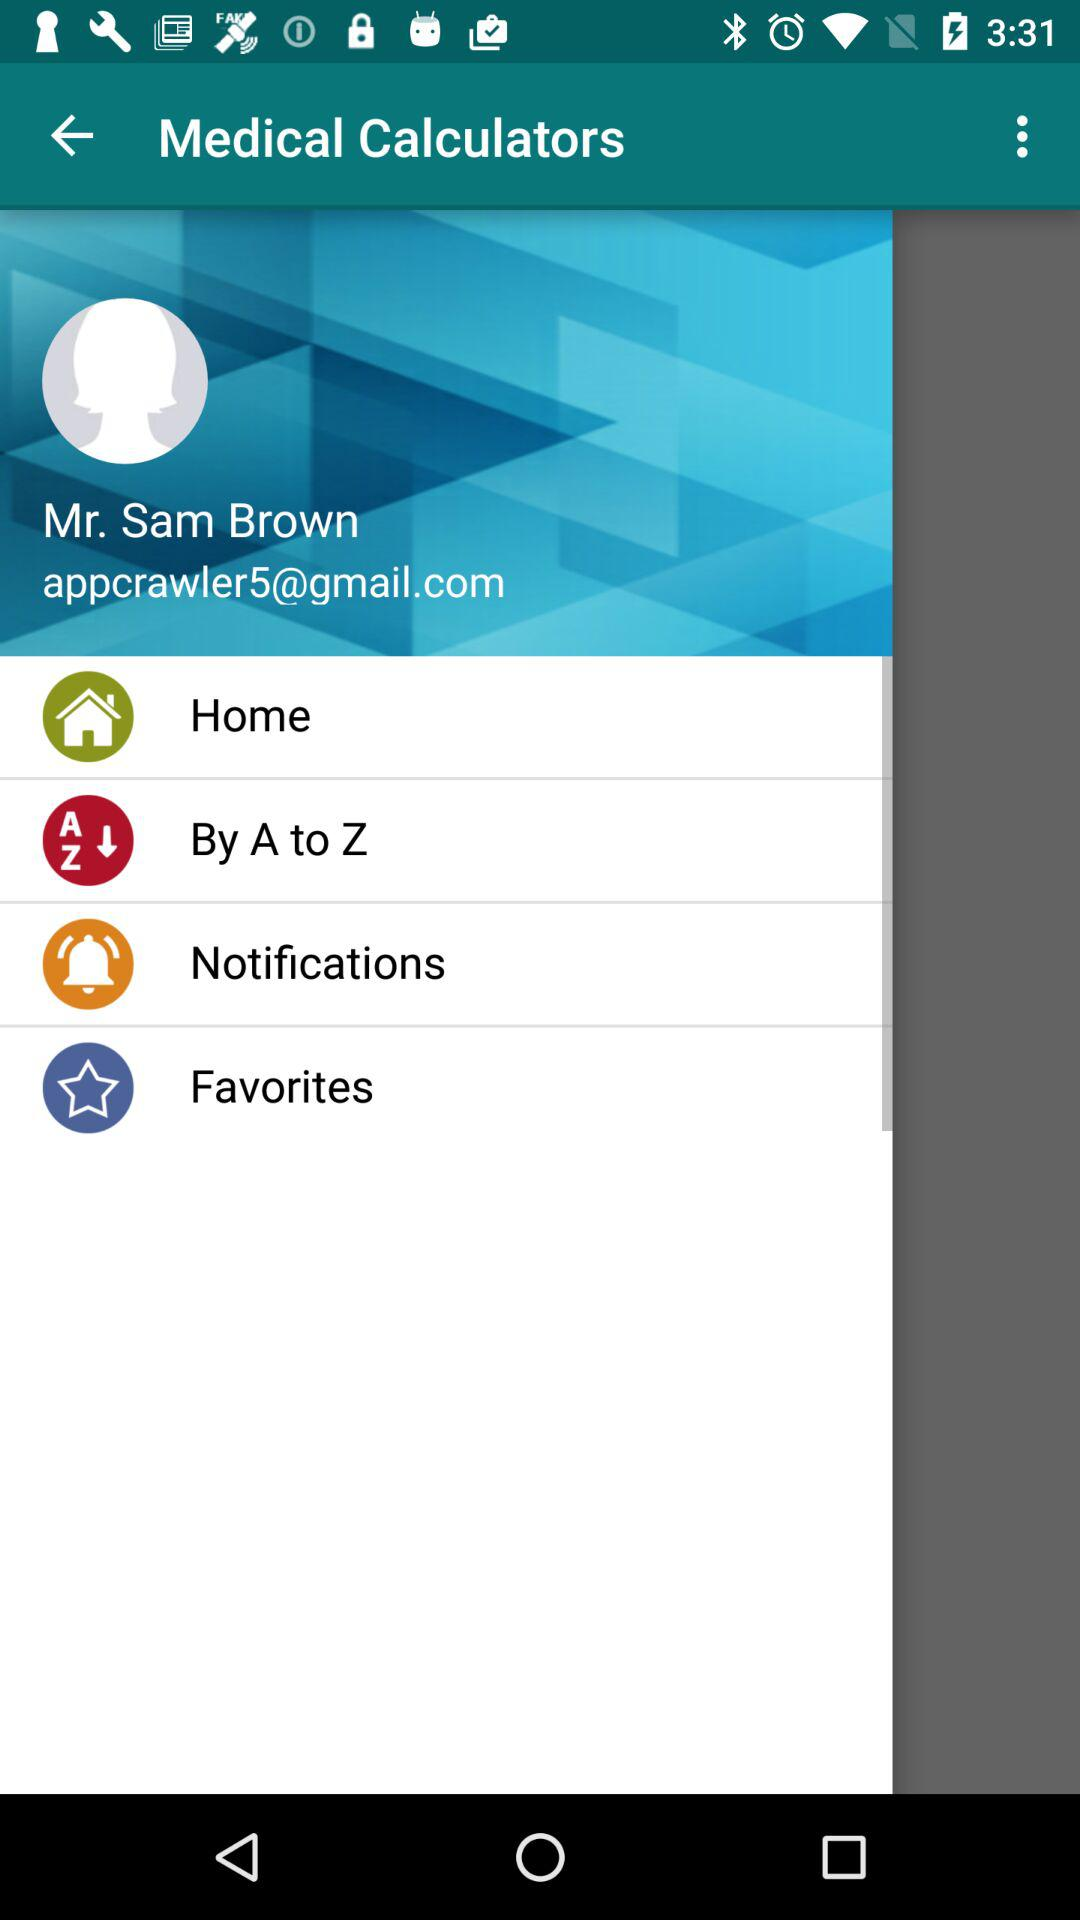What is the user name? The user name is Sam Brown. 